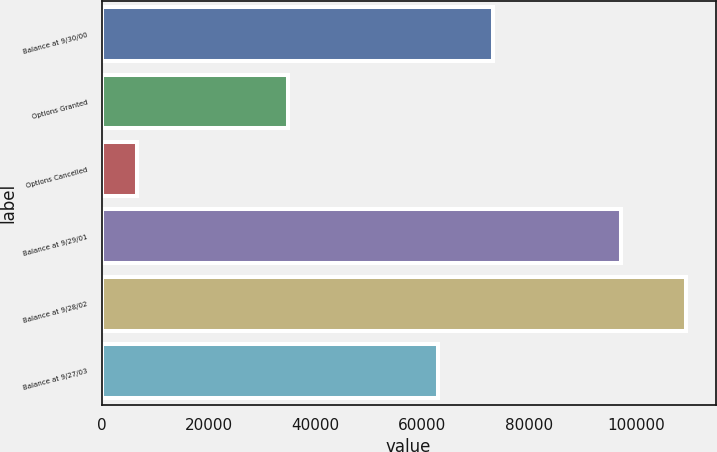Convert chart to OTSL. <chart><loc_0><loc_0><loc_500><loc_500><bar_chart><fcel>Balance at 9/30/00<fcel>Options Granted<fcel>Options Cancelled<fcel>Balance at 9/29/01<fcel>Balance at 9/28/02<fcel>Balance at 9/27/03<nl><fcel>73294.5<fcel>34857<fcel>6605<fcel>97179<fcel>109430<fcel>63012<nl></chart> 